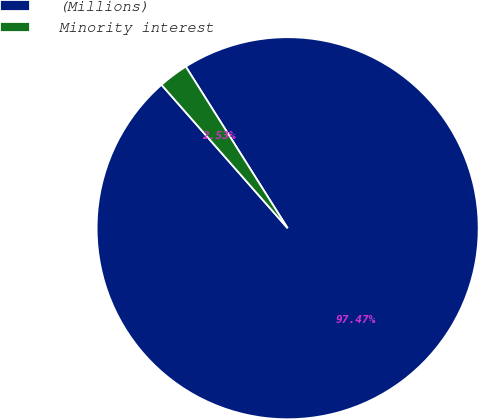Convert chart to OTSL. <chart><loc_0><loc_0><loc_500><loc_500><pie_chart><fcel>(Millions)<fcel>Minority interest<nl><fcel>97.47%<fcel>2.53%<nl></chart> 